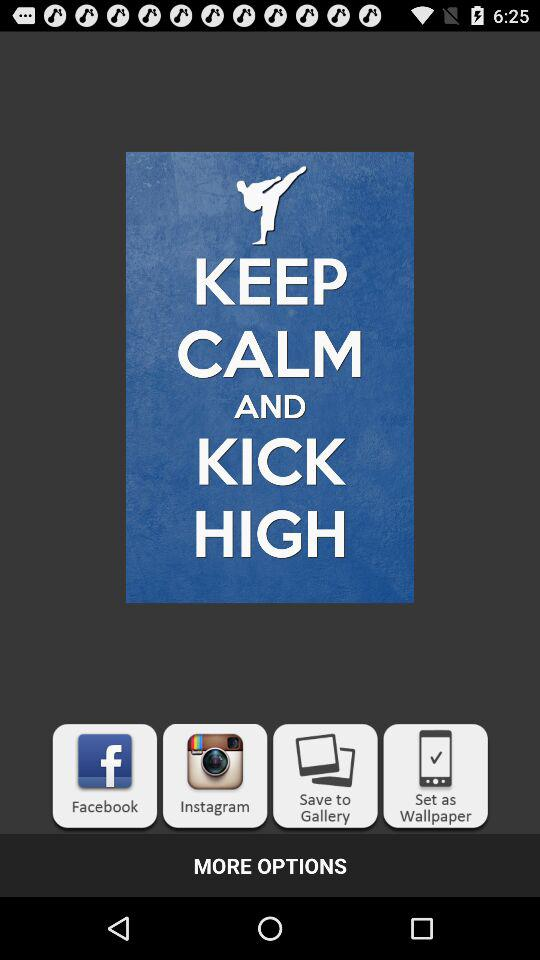What is the name of the application? The name of the application is "Clean Master". 